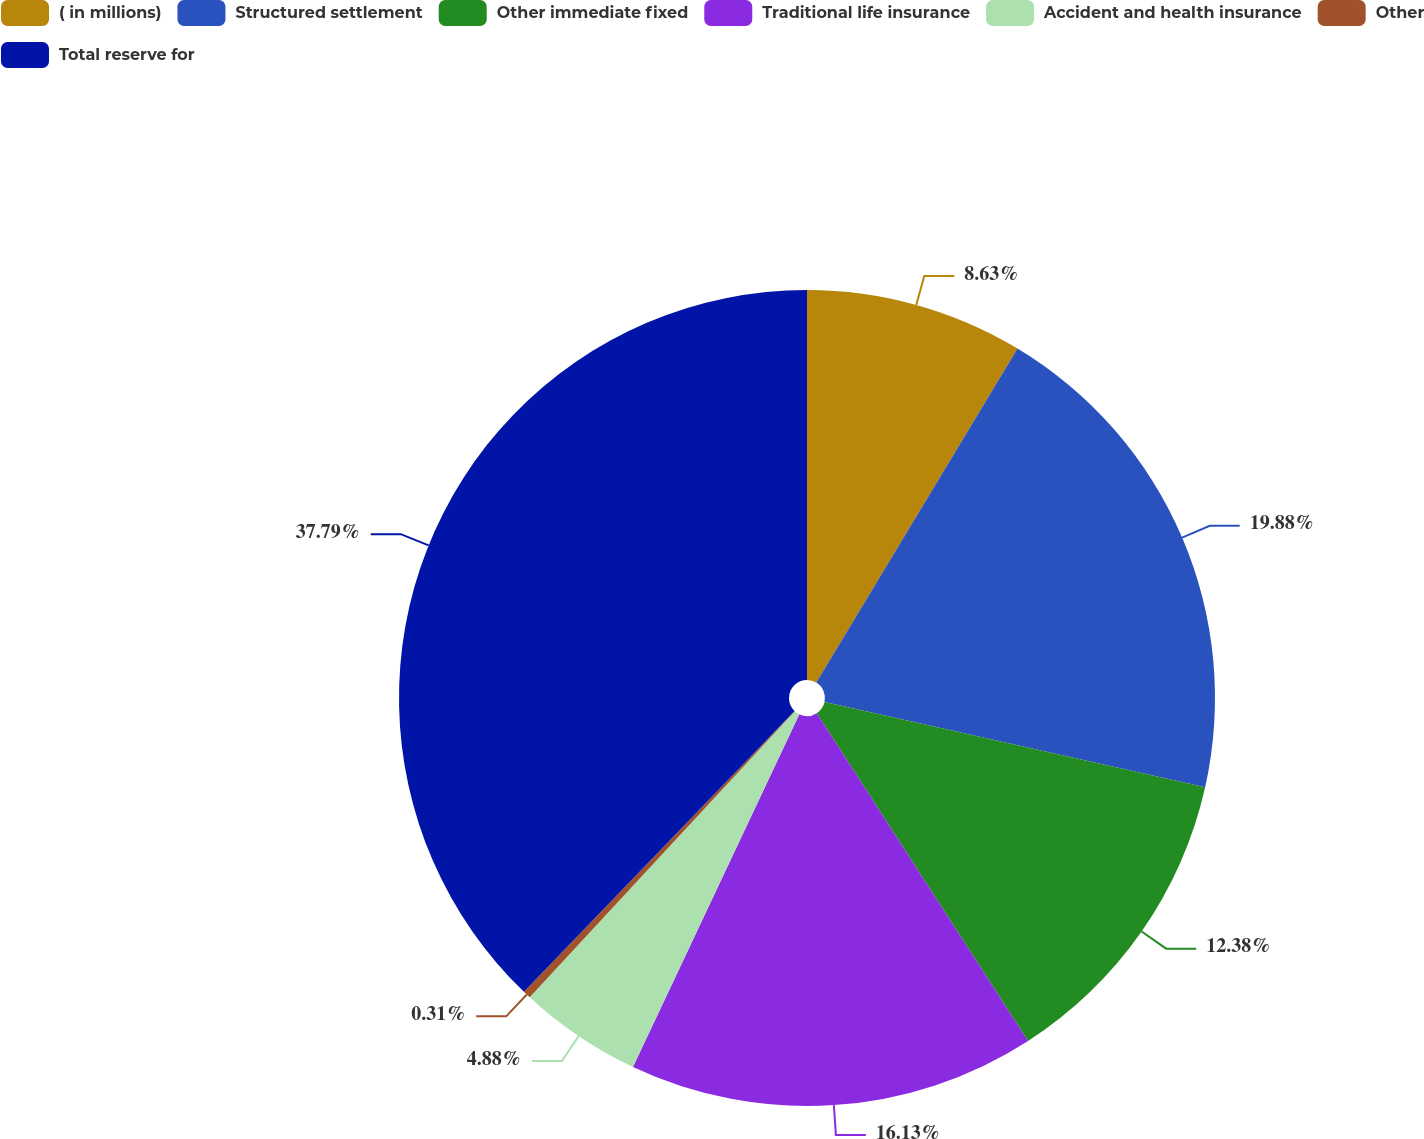Convert chart. <chart><loc_0><loc_0><loc_500><loc_500><pie_chart><fcel>( in millions)<fcel>Structured settlement<fcel>Other immediate fixed<fcel>Traditional life insurance<fcel>Accident and health insurance<fcel>Other<fcel>Total reserve for<nl><fcel>8.63%<fcel>19.88%<fcel>12.38%<fcel>16.13%<fcel>4.88%<fcel>0.31%<fcel>37.8%<nl></chart> 